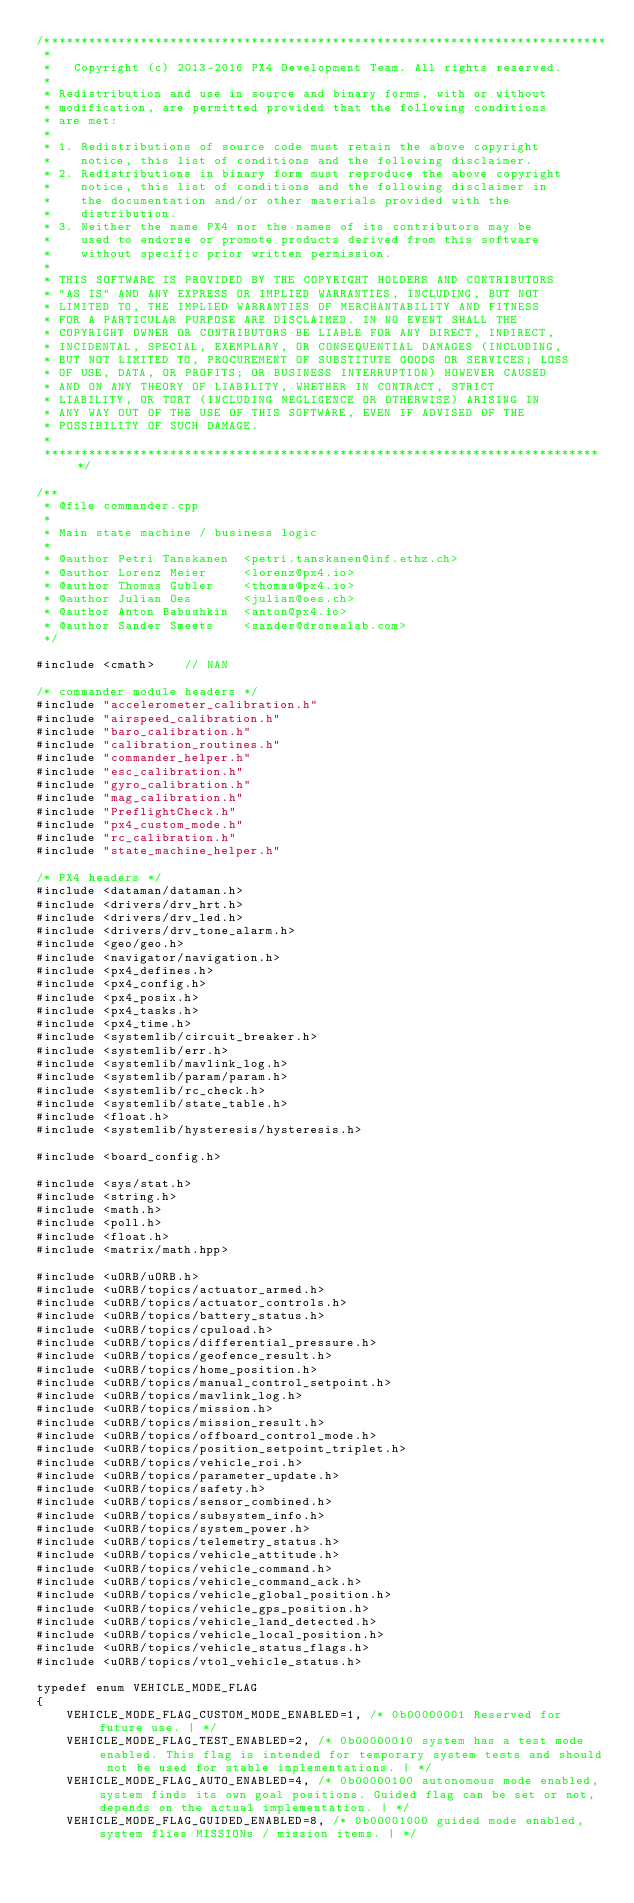Convert code to text. <code><loc_0><loc_0><loc_500><loc_500><_C++_>/****************************************************************************
 *
 *   Copyright (c) 2013-2016 PX4 Development Team. All rights reserved.
 *
 * Redistribution and use in source and binary forms, with or without
 * modification, are permitted provided that the following conditions
 * are met:
 *
 * 1. Redistributions of source code must retain the above copyright
 *    notice, this list of conditions and the following disclaimer.
 * 2. Redistributions in binary form must reproduce the above copyright
 *    notice, this list of conditions and the following disclaimer in
 *    the documentation and/or other materials provided with the
 *    distribution.
 * 3. Neither the name PX4 nor the names of its contributors may be
 *    used to endorse or promote products derived from this software
 *    without specific prior written permission.
 *
 * THIS SOFTWARE IS PROVIDED BY THE COPYRIGHT HOLDERS AND CONTRIBUTORS
 * "AS IS" AND ANY EXPRESS OR IMPLIED WARRANTIES, INCLUDING, BUT NOT
 * LIMITED TO, THE IMPLIED WARRANTIES OF MERCHANTABILITY AND FITNESS
 * FOR A PARTICULAR PURPOSE ARE DISCLAIMED. IN NO EVENT SHALL THE
 * COPYRIGHT OWNER OR CONTRIBUTORS BE LIABLE FOR ANY DIRECT, INDIRECT,
 * INCIDENTAL, SPECIAL, EXEMPLARY, OR CONSEQUENTIAL DAMAGES (INCLUDING,
 * BUT NOT LIMITED TO, PROCUREMENT OF SUBSTITUTE GOODS OR SERVICES; LOSS
 * OF USE, DATA, OR PROFITS; OR BUSINESS INTERRUPTION) HOWEVER CAUSED
 * AND ON ANY THEORY OF LIABILITY, WHETHER IN CONTRACT, STRICT
 * LIABILITY, OR TORT (INCLUDING NEGLIGENCE OR OTHERWISE) ARISING IN
 * ANY WAY OUT OF THE USE OF THIS SOFTWARE, EVEN IF ADVISED OF THE
 * POSSIBILITY OF SUCH DAMAGE.
 *
 ****************************************************************************/

/**
 * @file commander.cpp
 *
 * Main state machine / business logic
 *
 * @author Petri Tanskanen	<petri.tanskanen@inf.ethz.ch>
 * @author Lorenz Meier		<lorenz@px4.io>
 * @author Thomas Gubler	<thomas@px4.io>
 * @author Julian Oes		<julian@oes.ch>
 * @author Anton Babushkin	<anton@px4.io>
 * @author Sander Smeets	<sander@droneslab.com>
 */

#include <cmath>	// NAN

/* commander module headers */
#include "accelerometer_calibration.h"
#include "airspeed_calibration.h"
#include "baro_calibration.h"
#include "calibration_routines.h"
#include "commander_helper.h"
#include "esc_calibration.h"
#include "gyro_calibration.h"
#include "mag_calibration.h"
#include "PreflightCheck.h"
#include "px4_custom_mode.h"
#include "rc_calibration.h"
#include "state_machine_helper.h"

/* PX4 headers */
#include <dataman/dataman.h>
#include <drivers/drv_hrt.h>
#include <drivers/drv_led.h>
#include <drivers/drv_tone_alarm.h>
#include <geo/geo.h>
#include <navigator/navigation.h>
#include <px4_defines.h>
#include <px4_config.h>
#include <px4_posix.h>
#include <px4_tasks.h>
#include <px4_time.h>
#include <systemlib/circuit_breaker.h>
#include <systemlib/err.h>
#include <systemlib/mavlink_log.h>
#include <systemlib/param/param.h>
#include <systemlib/rc_check.h>
#include <systemlib/state_table.h>
#include <float.h>
#include <systemlib/hysteresis/hysteresis.h>

#include <board_config.h>

#include <sys/stat.h>
#include <string.h>
#include <math.h>
#include <poll.h>
#include <float.h>
#include <matrix/math.hpp>

#include <uORB/uORB.h>
#include <uORB/topics/actuator_armed.h>
#include <uORB/topics/actuator_controls.h>
#include <uORB/topics/battery_status.h>
#include <uORB/topics/cpuload.h>
#include <uORB/topics/differential_pressure.h>
#include <uORB/topics/geofence_result.h>
#include <uORB/topics/home_position.h>
#include <uORB/topics/manual_control_setpoint.h>
#include <uORB/topics/mavlink_log.h>
#include <uORB/topics/mission.h>
#include <uORB/topics/mission_result.h>
#include <uORB/topics/offboard_control_mode.h>
#include <uORB/topics/position_setpoint_triplet.h>
#include <uORB/topics/vehicle_roi.h>
#include <uORB/topics/parameter_update.h>
#include <uORB/topics/safety.h>
#include <uORB/topics/sensor_combined.h>
#include <uORB/topics/subsystem_info.h>
#include <uORB/topics/system_power.h>
#include <uORB/topics/telemetry_status.h>
#include <uORB/topics/vehicle_attitude.h>
#include <uORB/topics/vehicle_command.h>
#include <uORB/topics/vehicle_command_ack.h>
#include <uORB/topics/vehicle_global_position.h>
#include <uORB/topics/vehicle_gps_position.h>
#include <uORB/topics/vehicle_land_detected.h>
#include <uORB/topics/vehicle_local_position.h>
#include <uORB/topics/vehicle_status_flags.h>
#include <uORB/topics/vtol_vehicle_status.h>

typedef enum VEHICLE_MODE_FLAG
{
	VEHICLE_MODE_FLAG_CUSTOM_MODE_ENABLED=1, /* 0b00000001 Reserved for future use. | */
	VEHICLE_MODE_FLAG_TEST_ENABLED=2, /* 0b00000010 system has a test mode enabled. This flag is intended for temporary system tests and should not be used for stable implementations. | */
	VEHICLE_MODE_FLAG_AUTO_ENABLED=4, /* 0b00000100 autonomous mode enabled, system finds its own goal positions. Guided flag can be set or not, depends on the actual implementation. | */
	VEHICLE_MODE_FLAG_GUIDED_ENABLED=8, /* 0b00001000 guided mode enabled, system flies MISSIONs / mission items. | */</code> 